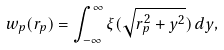<formula> <loc_0><loc_0><loc_500><loc_500>w _ { p } ( r _ { p } ) = \int ^ { \infty } _ { - \infty } \xi ( \sqrt { r _ { p } ^ { 2 } + y ^ { 2 } } ) \, d y ,</formula> 